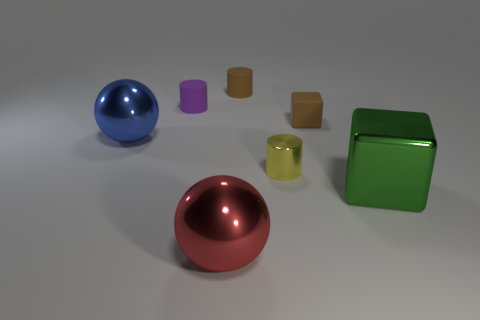There is a object that is the same color as the tiny rubber cube; what size is it?
Your answer should be compact. Small. What number of balls have the same color as the small cube?
Ensure brevity in your answer.  0. What size is the purple cylinder?
Ensure brevity in your answer.  Small. Does the green metallic object have the same size as the purple rubber cylinder?
Your response must be concise. No. There is a cylinder that is both behind the tiny yellow cylinder and to the right of the purple thing; what is its color?
Ensure brevity in your answer.  Brown. How many large blue cylinders have the same material as the large green cube?
Your answer should be very brief. 0. What number of tiny purple matte objects are there?
Provide a short and direct response. 1. Is the size of the purple matte object the same as the rubber cylinder that is on the right side of the big red sphere?
Your answer should be compact. Yes. What material is the small object in front of the sphere behind the green thing made of?
Provide a succinct answer. Metal. There is a shiny ball in front of the large shiny ball behind the red ball that is left of the brown block; how big is it?
Offer a very short reply. Large. 